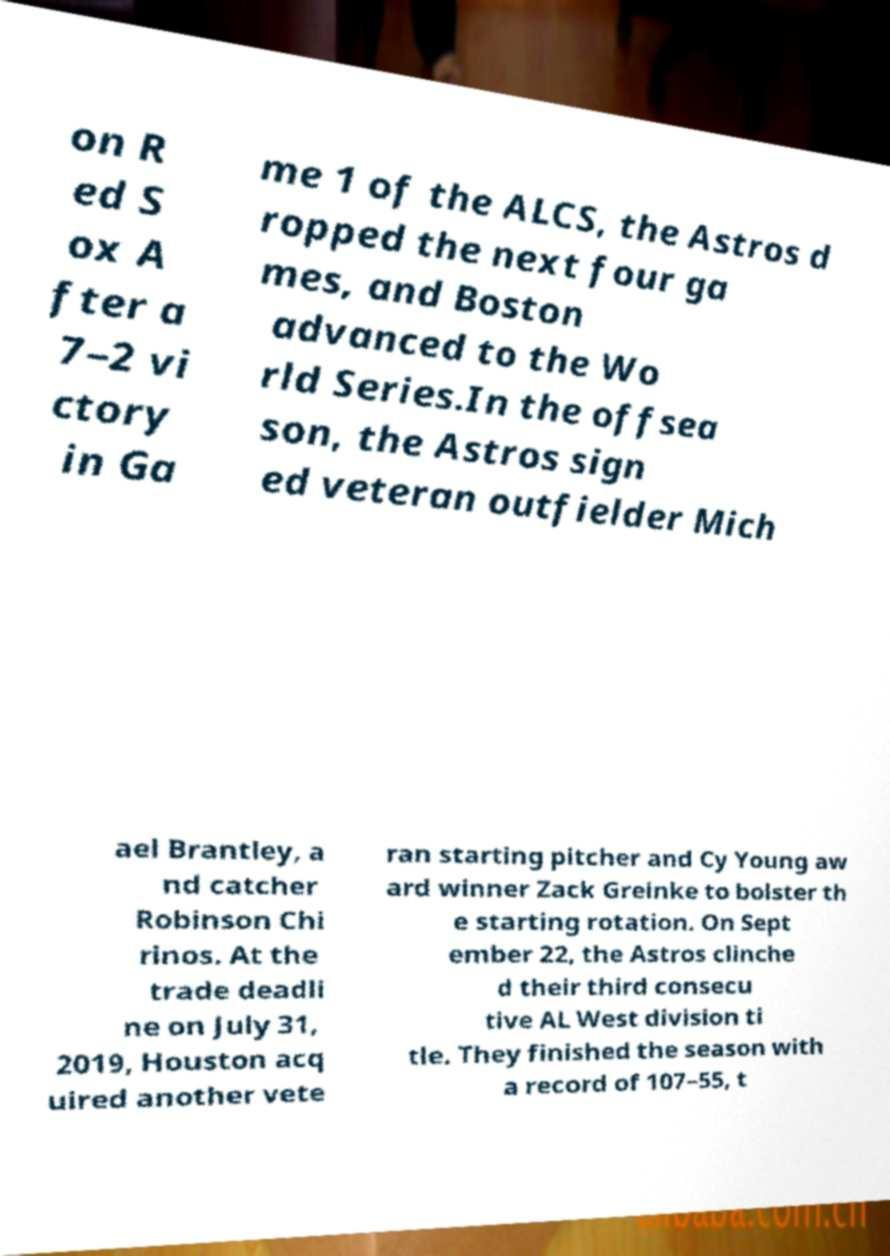Can you read and provide the text displayed in the image?This photo seems to have some interesting text. Can you extract and type it out for me? on R ed S ox A fter a 7–2 vi ctory in Ga me 1 of the ALCS, the Astros d ropped the next four ga mes, and Boston advanced to the Wo rld Series.In the offsea son, the Astros sign ed veteran outfielder Mich ael Brantley, a nd catcher Robinson Chi rinos. At the trade deadli ne on July 31, 2019, Houston acq uired another vete ran starting pitcher and Cy Young aw ard winner Zack Greinke to bolster th e starting rotation. On Sept ember 22, the Astros clinche d their third consecu tive AL West division ti tle. They finished the season with a record of 107–55, t 